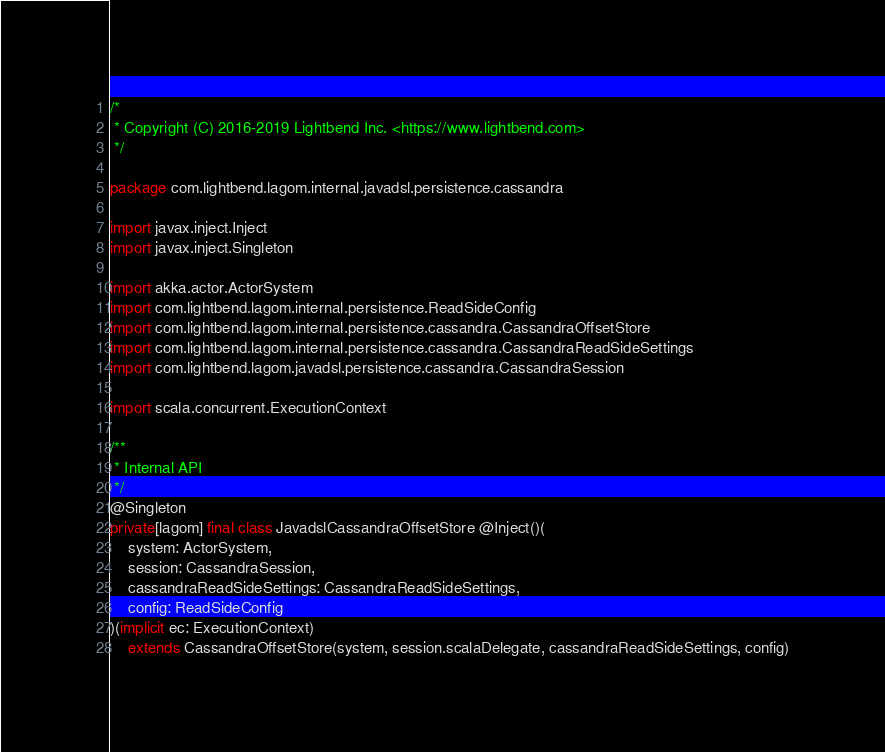Convert code to text. <code><loc_0><loc_0><loc_500><loc_500><_Scala_>/*
 * Copyright (C) 2016-2019 Lightbend Inc. <https://www.lightbend.com>
 */

package com.lightbend.lagom.internal.javadsl.persistence.cassandra

import javax.inject.Inject
import javax.inject.Singleton

import akka.actor.ActorSystem
import com.lightbend.lagom.internal.persistence.ReadSideConfig
import com.lightbend.lagom.internal.persistence.cassandra.CassandraOffsetStore
import com.lightbend.lagom.internal.persistence.cassandra.CassandraReadSideSettings
import com.lightbend.lagom.javadsl.persistence.cassandra.CassandraSession

import scala.concurrent.ExecutionContext

/**
 * Internal API
 */
@Singleton
private[lagom] final class JavadslCassandraOffsetStore @Inject()(
    system: ActorSystem,
    session: CassandraSession,
    cassandraReadSideSettings: CassandraReadSideSettings,
    config: ReadSideConfig
)(implicit ec: ExecutionContext)
    extends CassandraOffsetStore(system, session.scalaDelegate, cassandraReadSideSettings, config)
</code> 